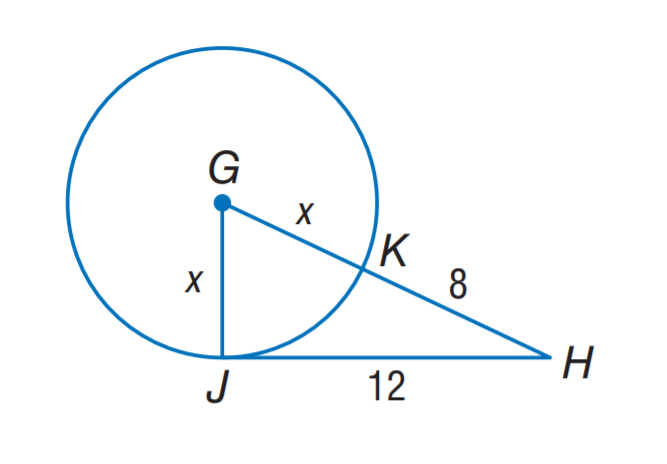Question: J H is tangent to \odot G at J. Find the value of x.
Choices:
A. 3
B. 5
C. 8
D. 12
Answer with the letter. Answer: B 